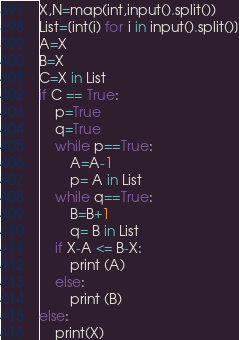<code> <loc_0><loc_0><loc_500><loc_500><_Python_>X,N=map(int,input().split())
List=[int(i) for i in input().split()]
A=X
B=X
C=X in List
if C == True:    
    p=True
    q=True
    while p==True:
        A=A-1
        p= A in List
    while q==True:
        B=B+1
        q= B in List
    if X-A <= B-X:
        print (A)
    else:
        print (B)
else:
    print(X)</code> 